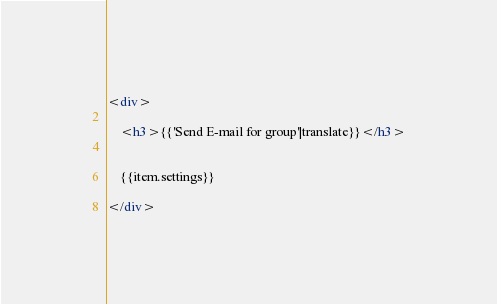Convert code to text. <code><loc_0><loc_0><loc_500><loc_500><_HTML_><div>

    <h3>{{'Send E-mail for group'|translate}}</h3>


    {{item.settings}}

</div></code> 